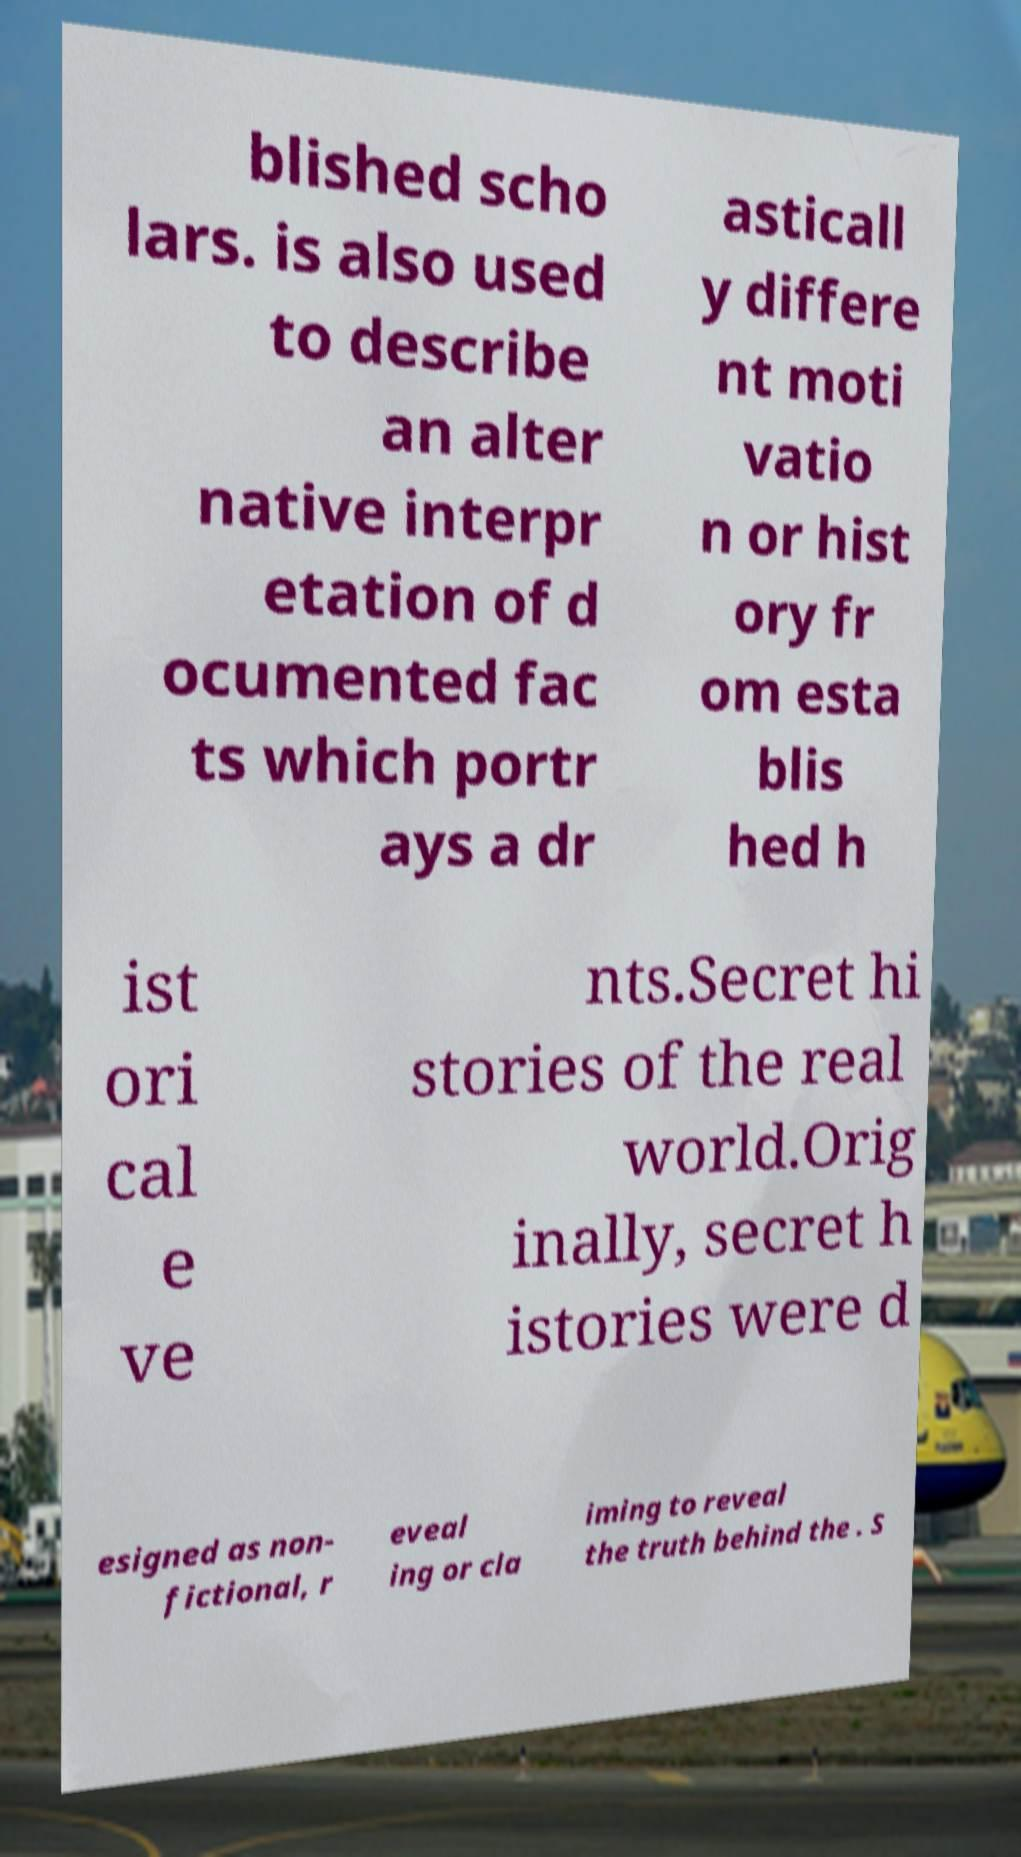For documentation purposes, I need the text within this image transcribed. Could you provide that? blished scho lars. is also used to describe an alter native interpr etation of d ocumented fac ts which portr ays a dr asticall y differe nt moti vatio n or hist ory fr om esta blis hed h ist ori cal e ve nts.Secret hi stories of the real world.Orig inally, secret h istories were d esigned as non- fictional, r eveal ing or cla iming to reveal the truth behind the . S 